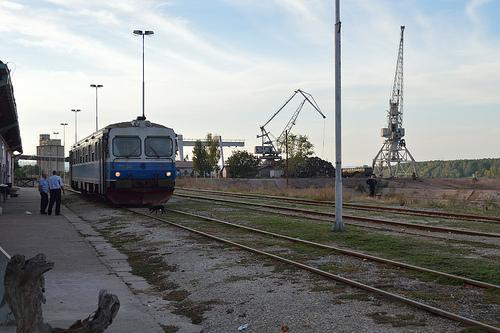How many light poles are visible?
Give a very brief answer. 6. How many men are pictured?
Give a very brief answer. 2. 